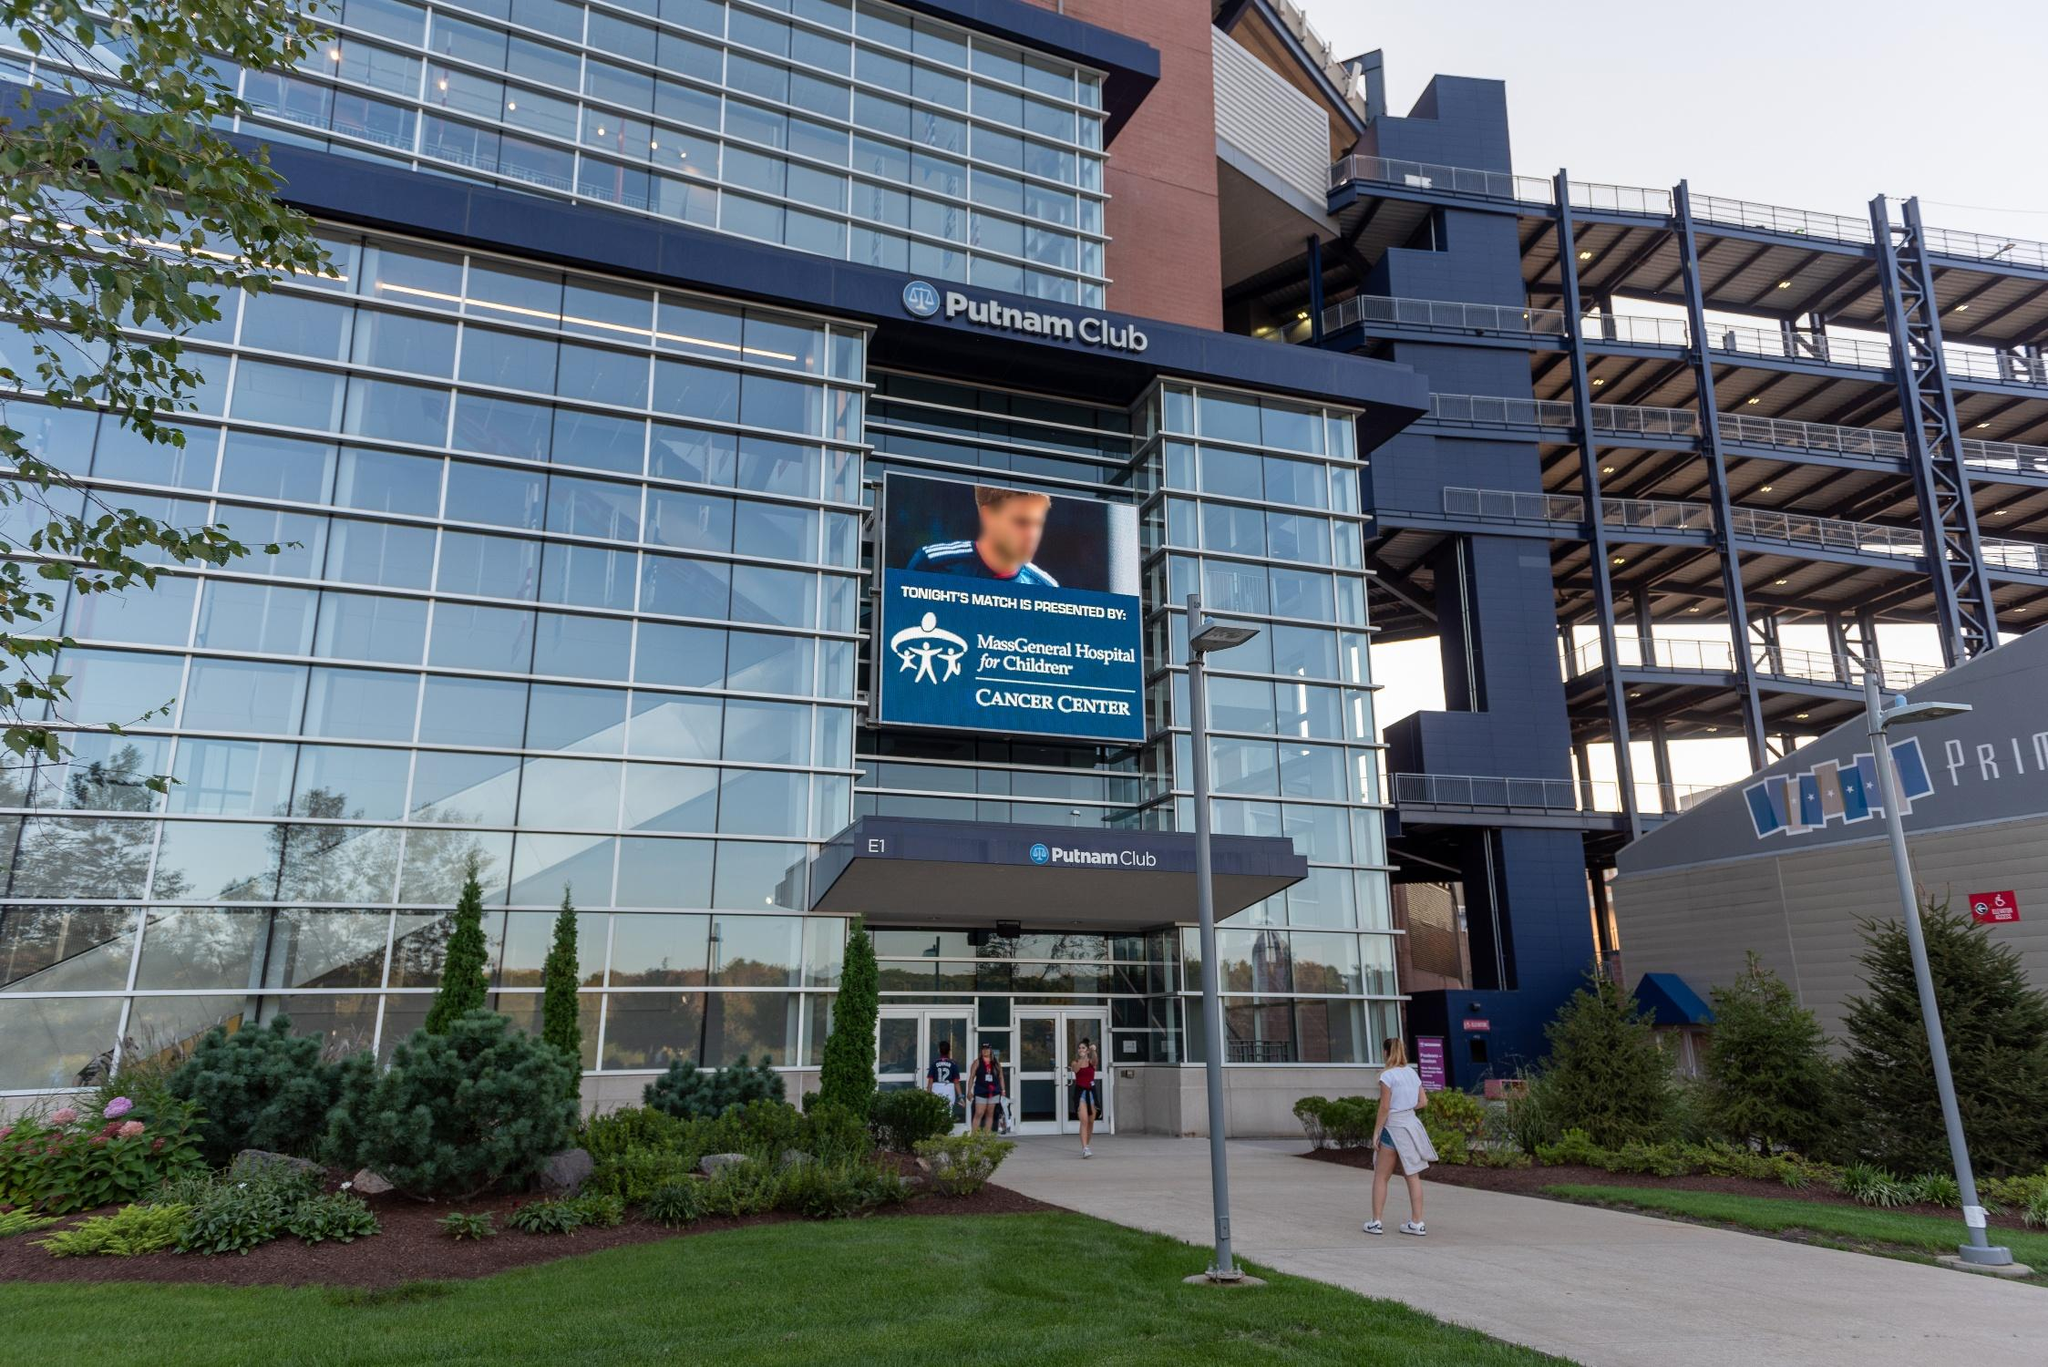Analyze the image in a comprehensive and detailed manner. The image captures the exterior of the Putnam Club, situated within a sports and entertainment venue in Foxborough, Massachusetts. The building presents a modern design, prominently featuring steel and glass elements that mirror the clear blue sky. The main entrance is impeccably landscaped, with verdant trees and shrubs providing a natural contrast to the urban structure. Above the entrance, a large digital screen advertises the MassGeneral Hospital for Children Cancer Center, illustrating the venue's engagement with health-related organizations. The photo, taken from a low angle, amplifies the building's grandeur and imposing stature. The architectural details, including the lattice structure on the right and the seamless glass façade, combined with the pristine sky, create a visually striking composition. Noticeably absent is any indication of the landmark identifier 'sa_16770,' limiting specific locational identification in this context. 